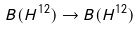<formula> <loc_0><loc_0><loc_500><loc_500>B ( H ^ { 1 2 } ) \rightarrow B ( H ^ { 1 2 } )</formula> 